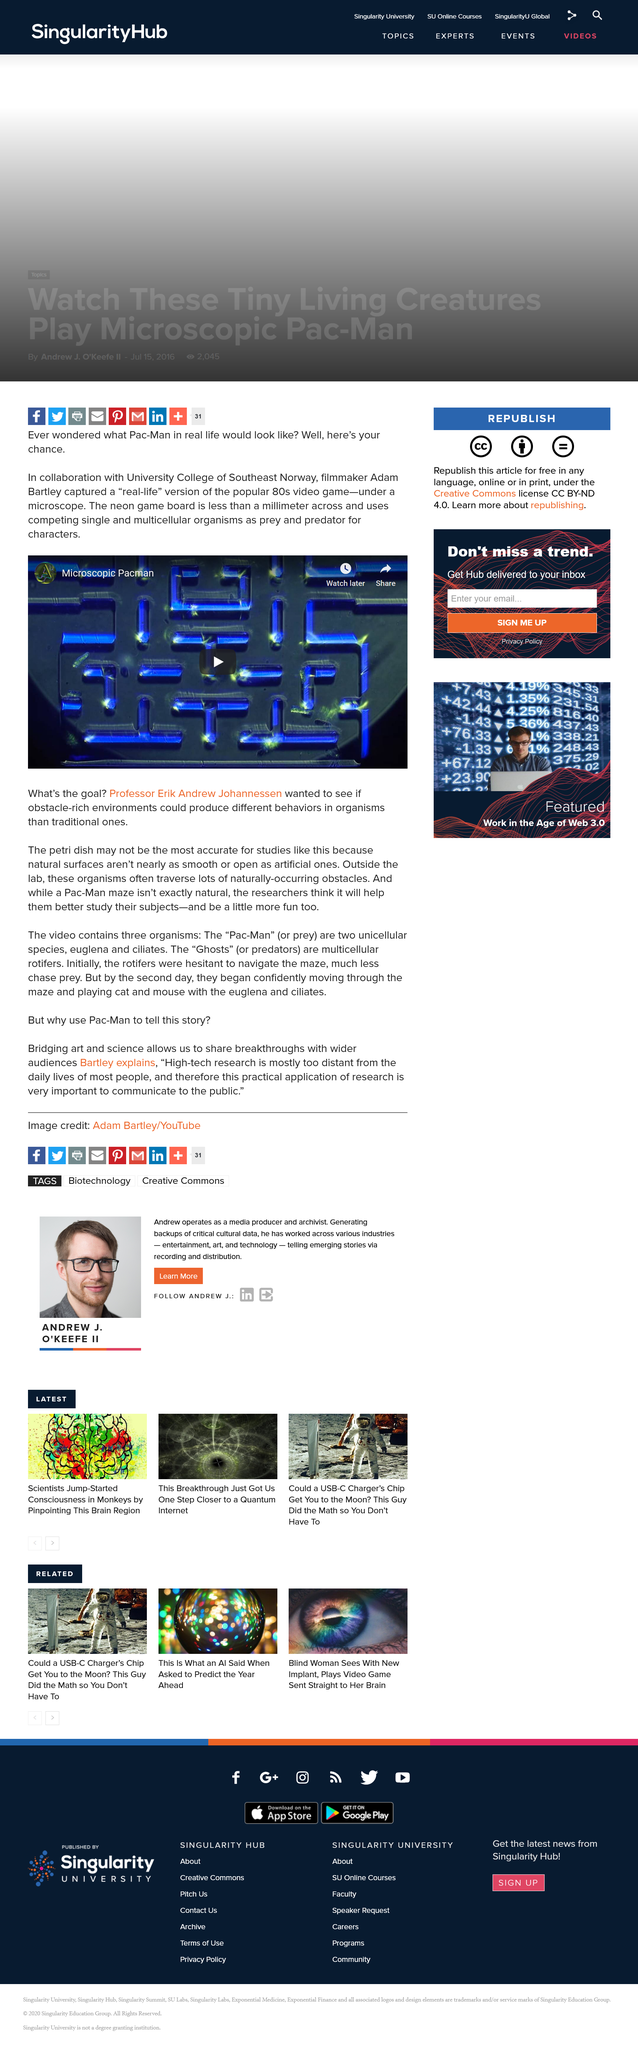Highlight a few significant elements in this photo. The filmmaker who portrayed a "real-life" version of the popular 80s video game under a microscope is Adam Bartley. Petri dishes are not the most accurate environment for studying bacteria and viruses because natural surfaces are different from artificial ones, and the results obtained from petri dishes may not accurately reflect what happens in a natural environment. In this recreation, the game board is significantly smaller than a millimeter in size. 